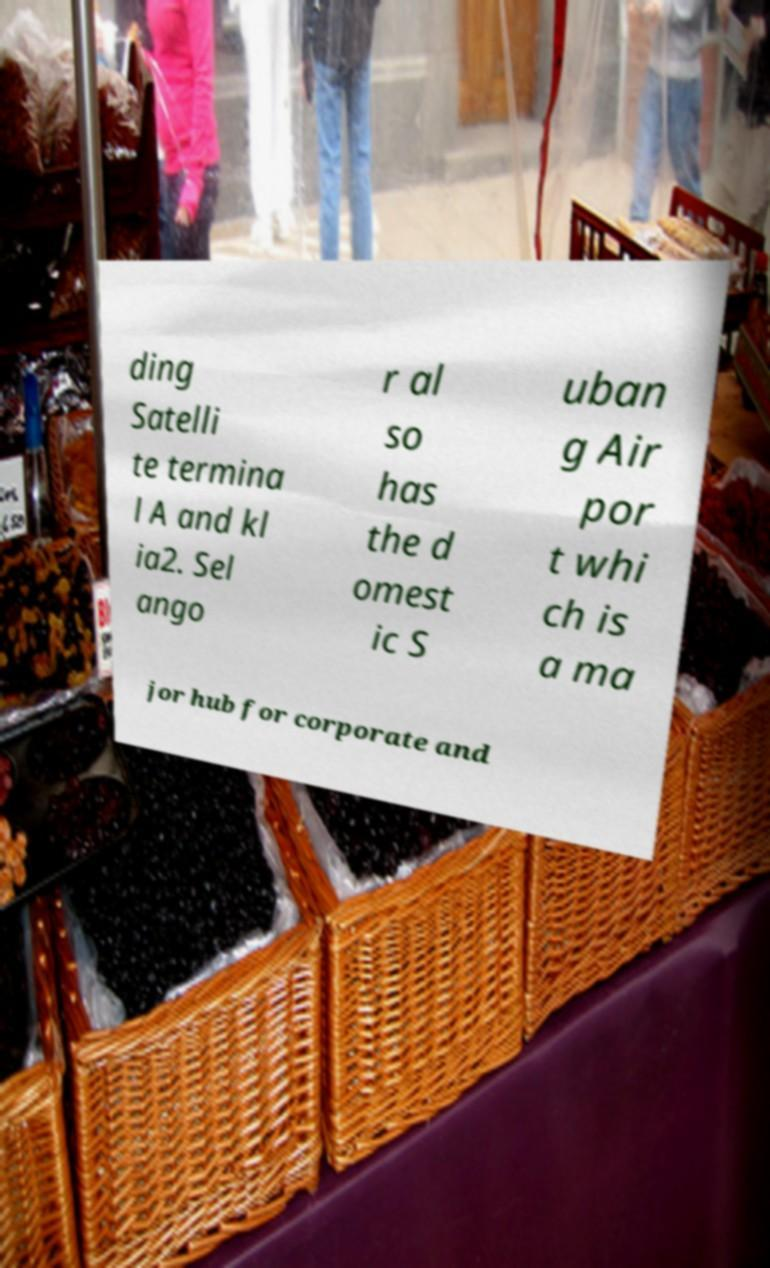What messages or text are displayed in this image? I need them in a readable, typed format. ding Satelli te termina l A and kl ia2. Sel ango r al so has the d omest ic S uban g Air por t whi ch is a ma jor hub for corporate and 